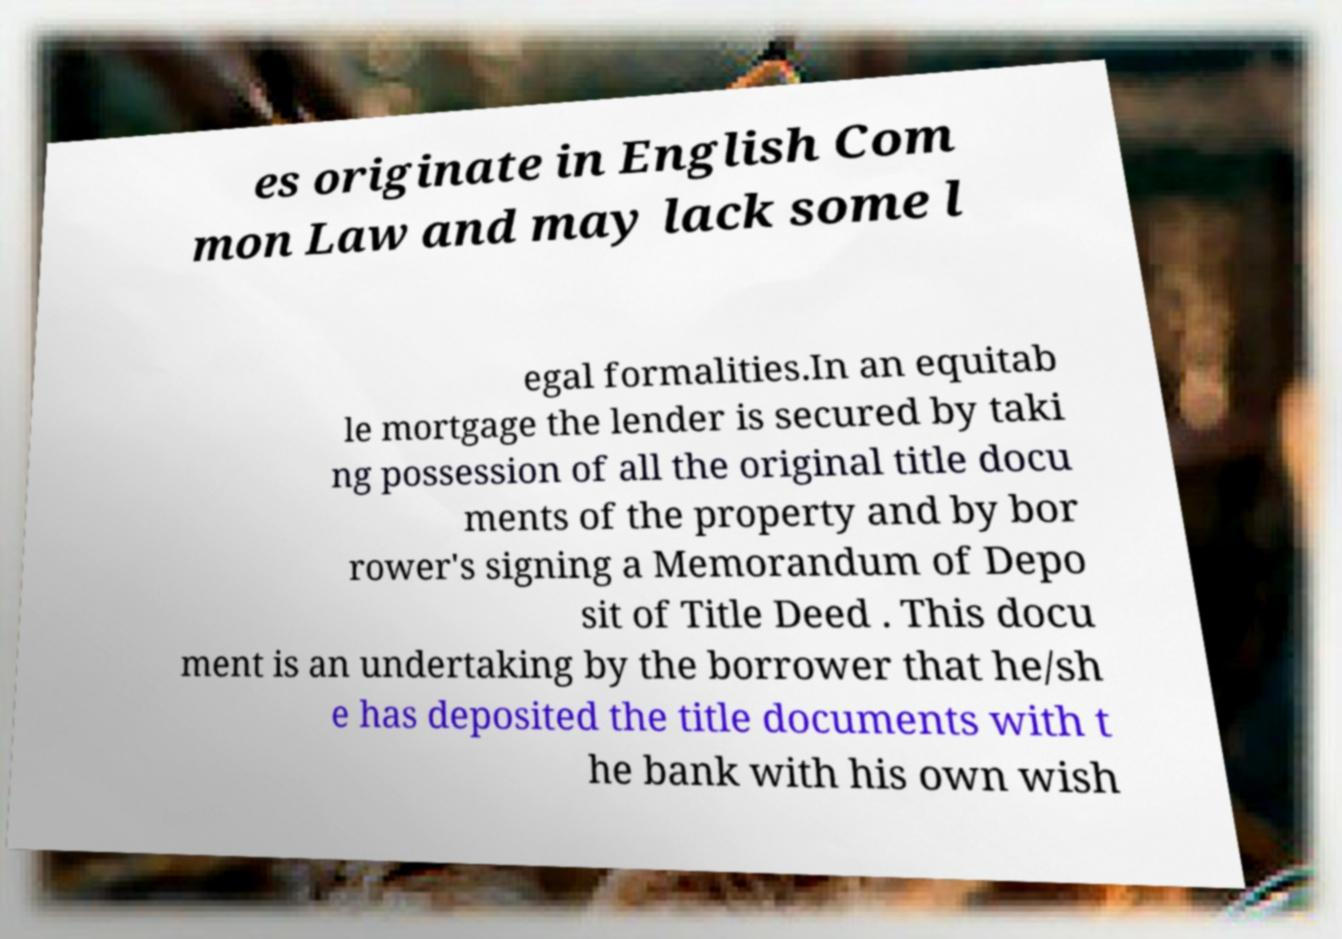There's text embedded in this image that I need extracted. Can you transcribe it verbatim? es originate in English Com mon Law and may lack some l egal formalities.In an equitab le mortgage the lender is secured by taki ng possession of all the original title docu ments of the property and by bor rower's signing a Memorandum of Depo sit of Title Deed . This docu ment is an undertaking by the borrower that he/sh e has deposited the title documents with t he bank with his own wish 